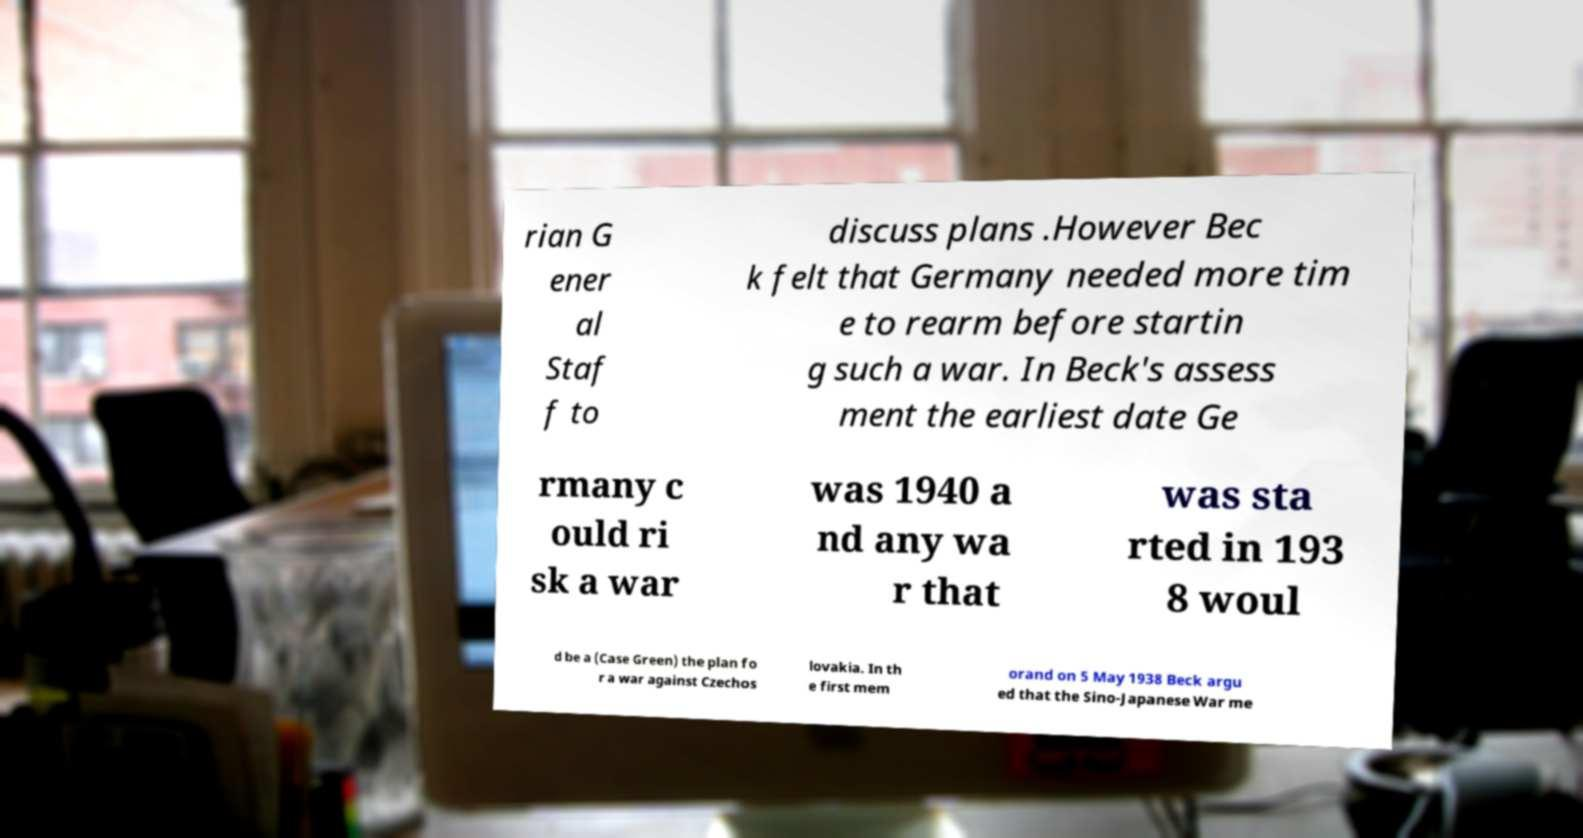Could you extract and type out the text from this image? rian G ener al Staf f to discuss plans .However Bec k felt that Germany needed more tim e to rearm before startin g such a war. In Beck's assess ment the earliest date Ge rmany c ould ri sk a war was 1940 a nd any wa r that was sta rted in 193 8 woul d be a (Case Green) the plan fo r a war against Czechos lovakia. In th e first mem orand on 5 May 1938 Beck argu ed that the Sino-Japanese War me 